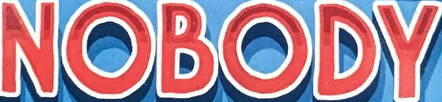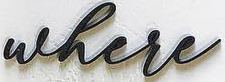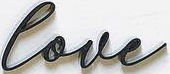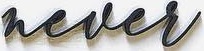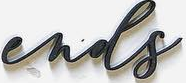Transcribe the words shown in these images in order, separated by a semicolon. NOBODY; where; love; never; ends 